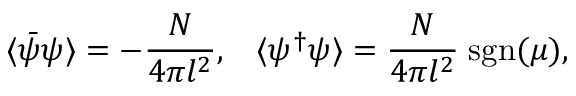<formula> <loc_0><loc_0><loc_500><loc_500>\langle \bar { \psi } \psi \rangle = - \frac { N } { 4 \pi l ^ { 2 } } , \, \langle \psi ^ { \dagger } \psi \rangle = \frac { N } { 4 \pi l ^ { 2 } } \, s g n ( \mu ) ,</formula> 